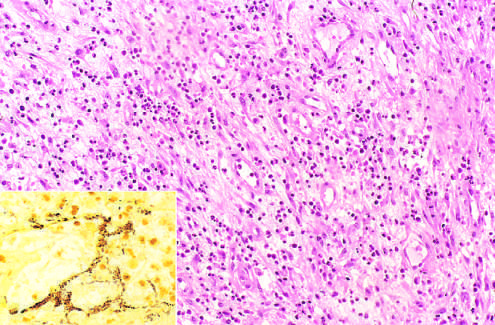what are histologic features?
Answer the question using a single word or phrase. Acute inflammation and capillary proliferation 